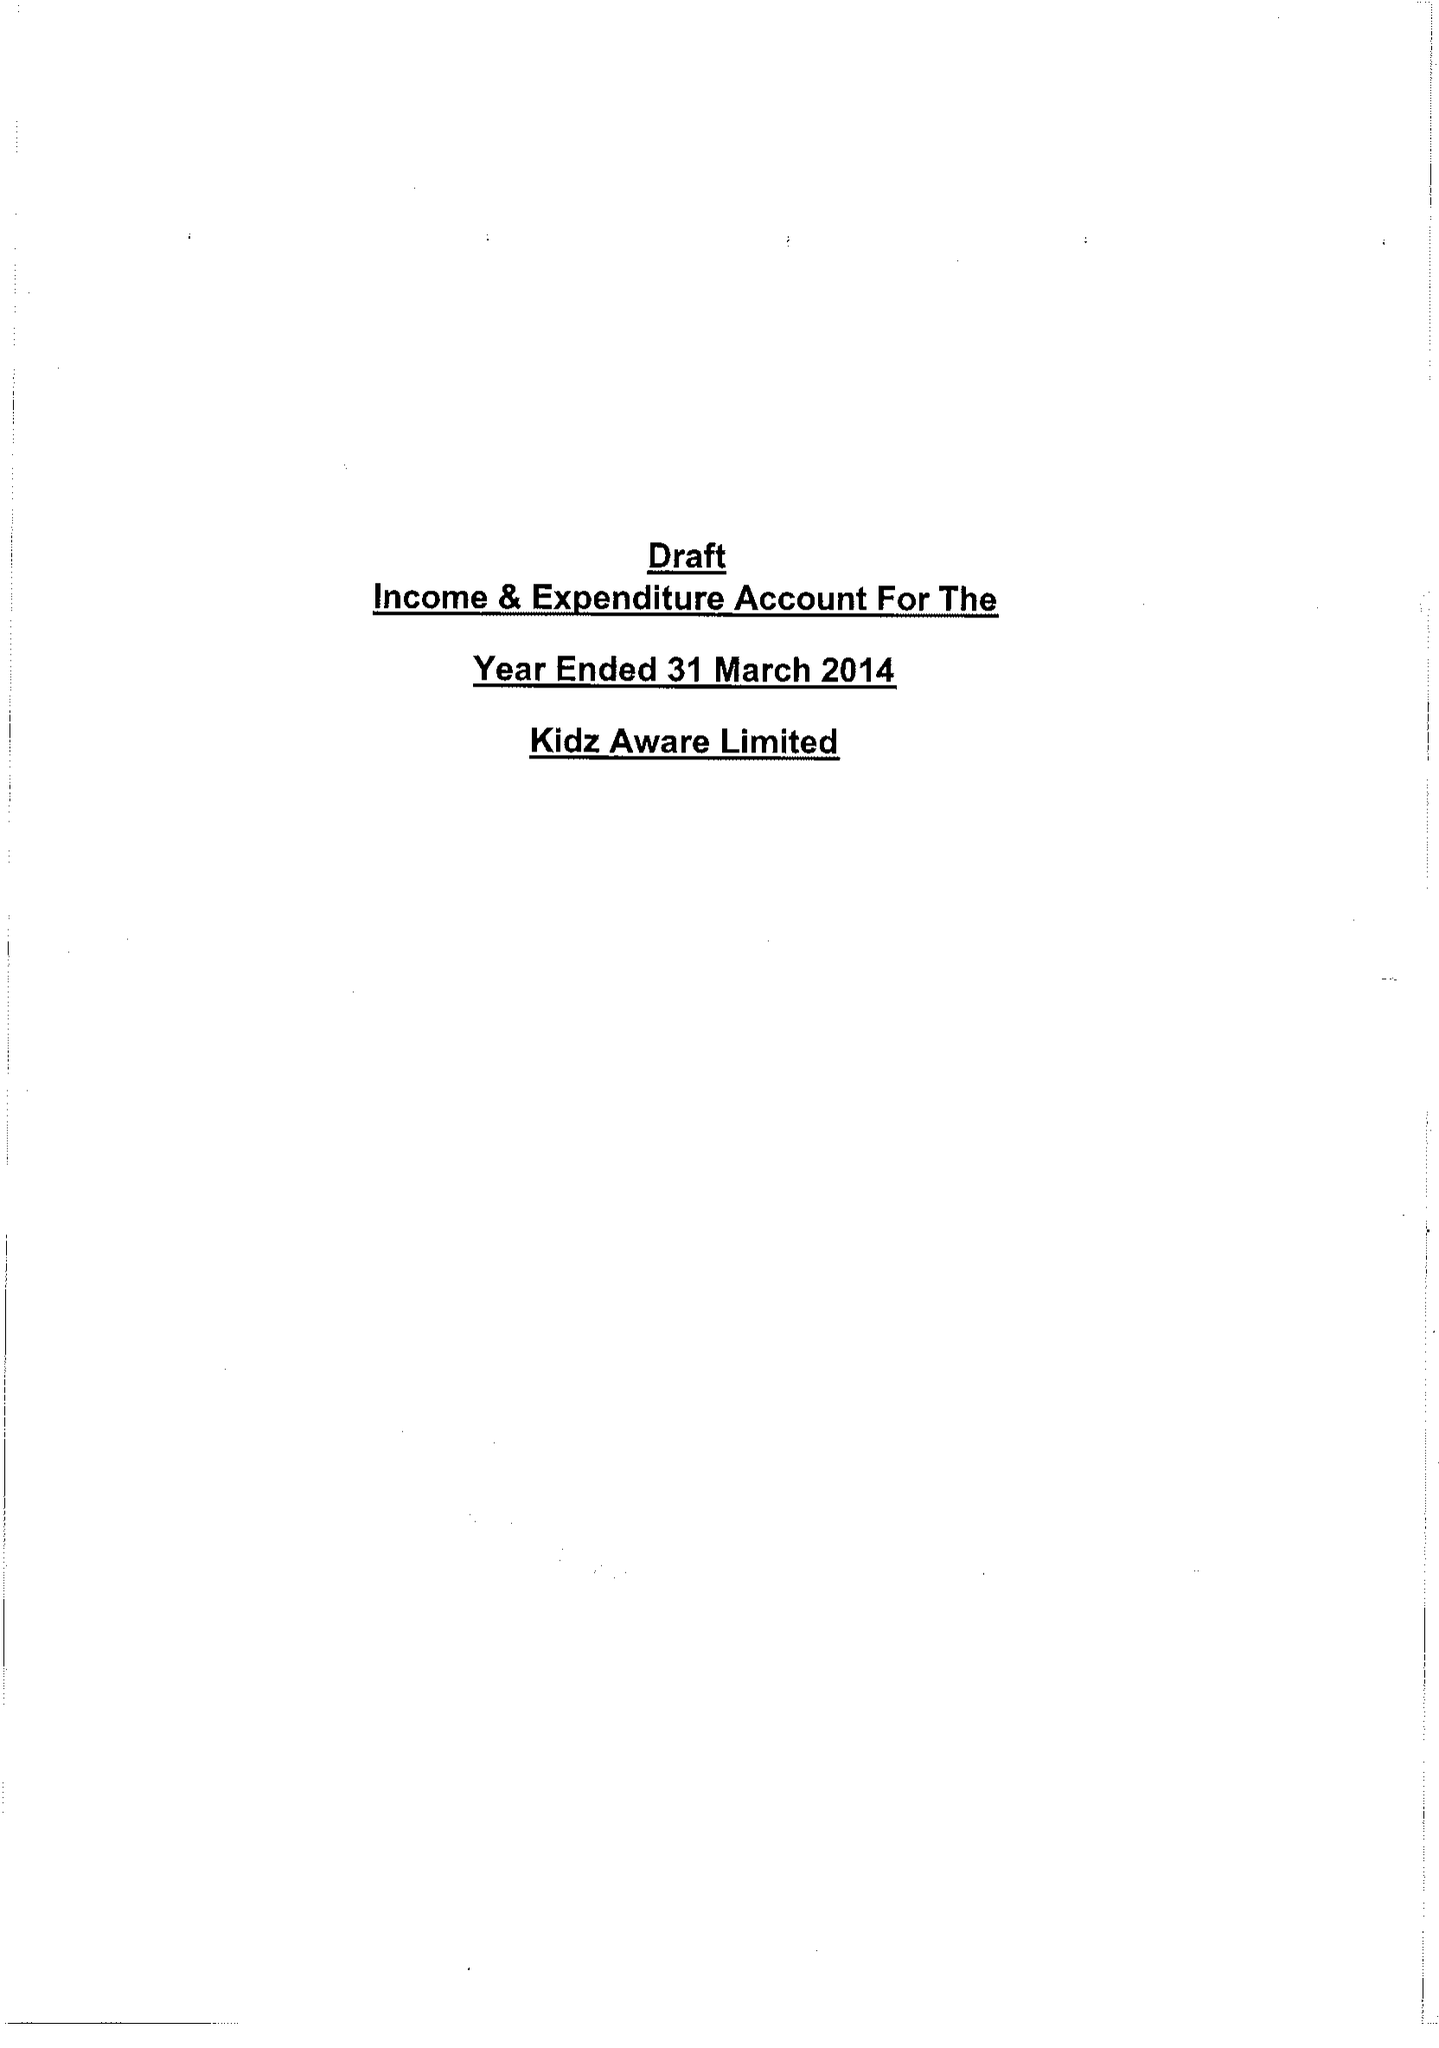What is the value for the address__postcode?
Answer the question using a single word or phrase. WF2 7AZ 